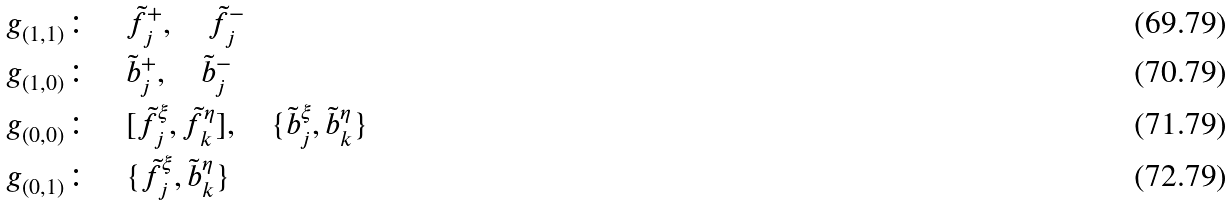<formula> <loc_0><loc_0><loc_500><loc_500>& \ g _ { ( 1 , 1 ) } \colon \quad \tilde { f } _ { j } ^ { + } , \quad \tilde { f } _ { j } ^ { - } \\ & \ g _ { ( 1 , 0 ) } \colon \quad \tilde { b } _ { j } ^ { + } , \quad \tilde { b } _ { j } ^ { - } \\ & \ g _ { ( 0 , 0 ) } \colon \quad [ \tilde { f } _ { j } ^ { \xi } , \tilde { f } _ { k } ^ { \eta } ] , \quad \{ \tilde { b } _ { j } ^ { \xi } , \tilde { b } _ { k } ^ { \eta } \} \\ & \ g _ { ( 0 , 1 ) } \colon \quad \{ \tilde { f } _ { j } ^ { \xi } , \tilde { b } _ { k } ^ { \eta } \}</formula> 